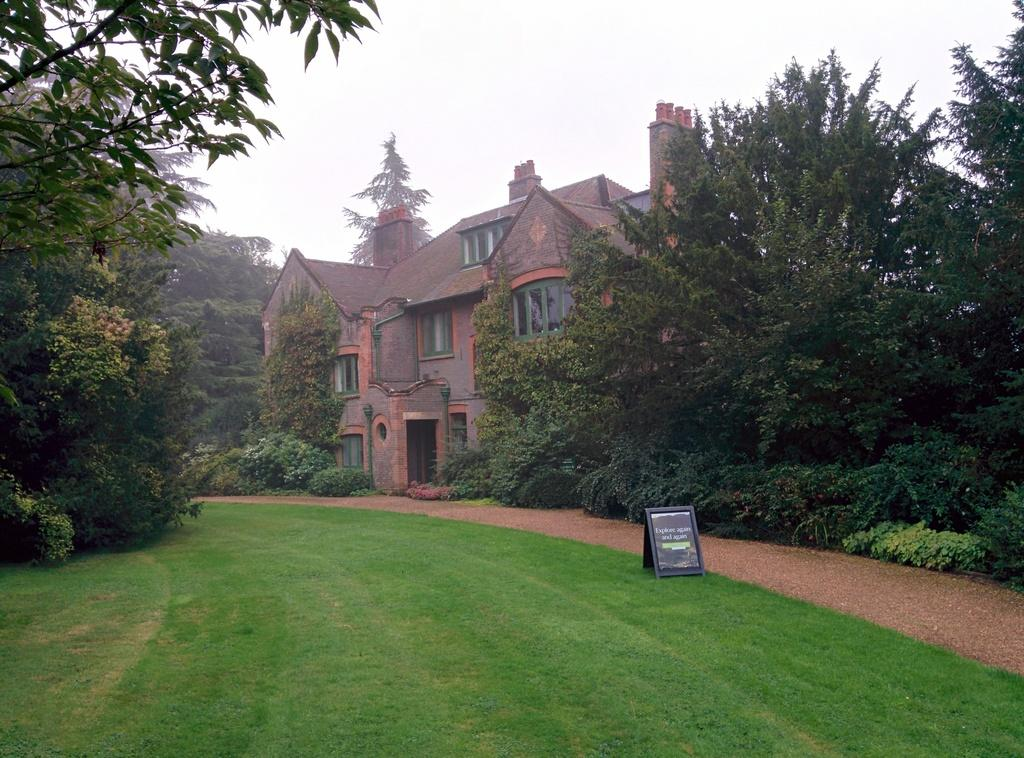What type of structures are visible in the image? There are buildings with windows in the image. What features are present on the buildings? There are doors on the buildings. What can be seen on the ground in the image? Grass is present on the ground. What type of vegetation is visible in the image? There are trees and plants in the image. What is visible in the background of the image? The sky is visible in the image. What additional object can be seen in the image? There is a poster in the image. Where is the shelf located in the image? There is no shelf present in the image. What type of question is being asked in the image? There is no question being asked in the image. 